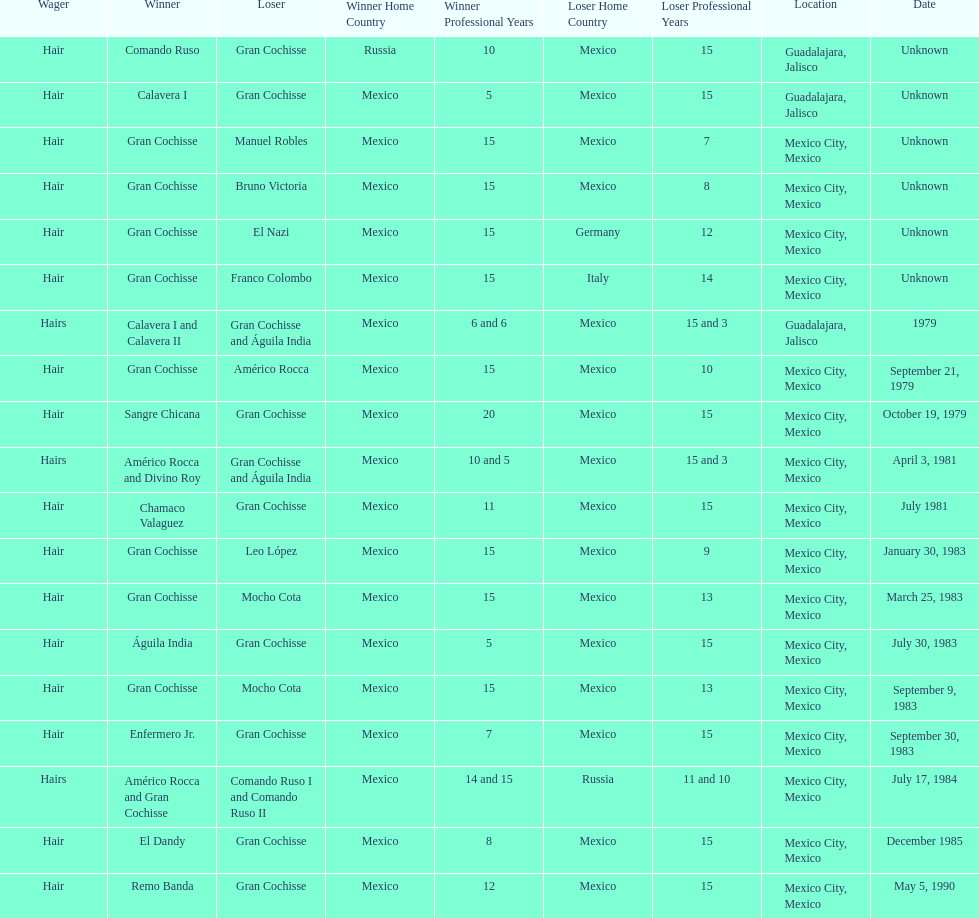How many times has the wager been hair? 16. 